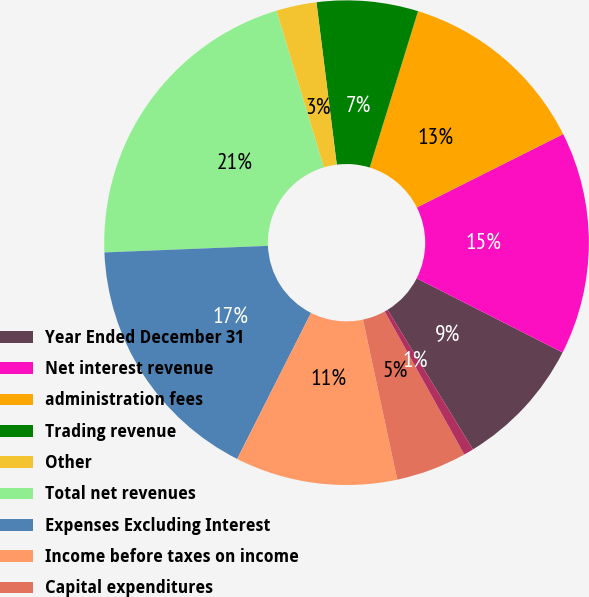<chart> <loc_0><loc_0><loc_500><loc_500><pie_chart><fcel>Year Ended December 31<fcel>Net interest revenue<fcel>administration fees<fcel>Trading revenue<fcel>Other<fcel>Total net revenues<fcel>Expenses Excluding Interest<fcel>Income before taxes on income<fcel>Capital expenditures<fcel>Depreciation and amortization<nl><fcel>8.78%<fcel>14.88%<fcel>12.84%<fcel>6.75%<fcel>2.69%<fcel>20.97%<fcel>16.91%<fcel>10.81%<fcel>4.72%<fcel>0.66%<nl></chart> 